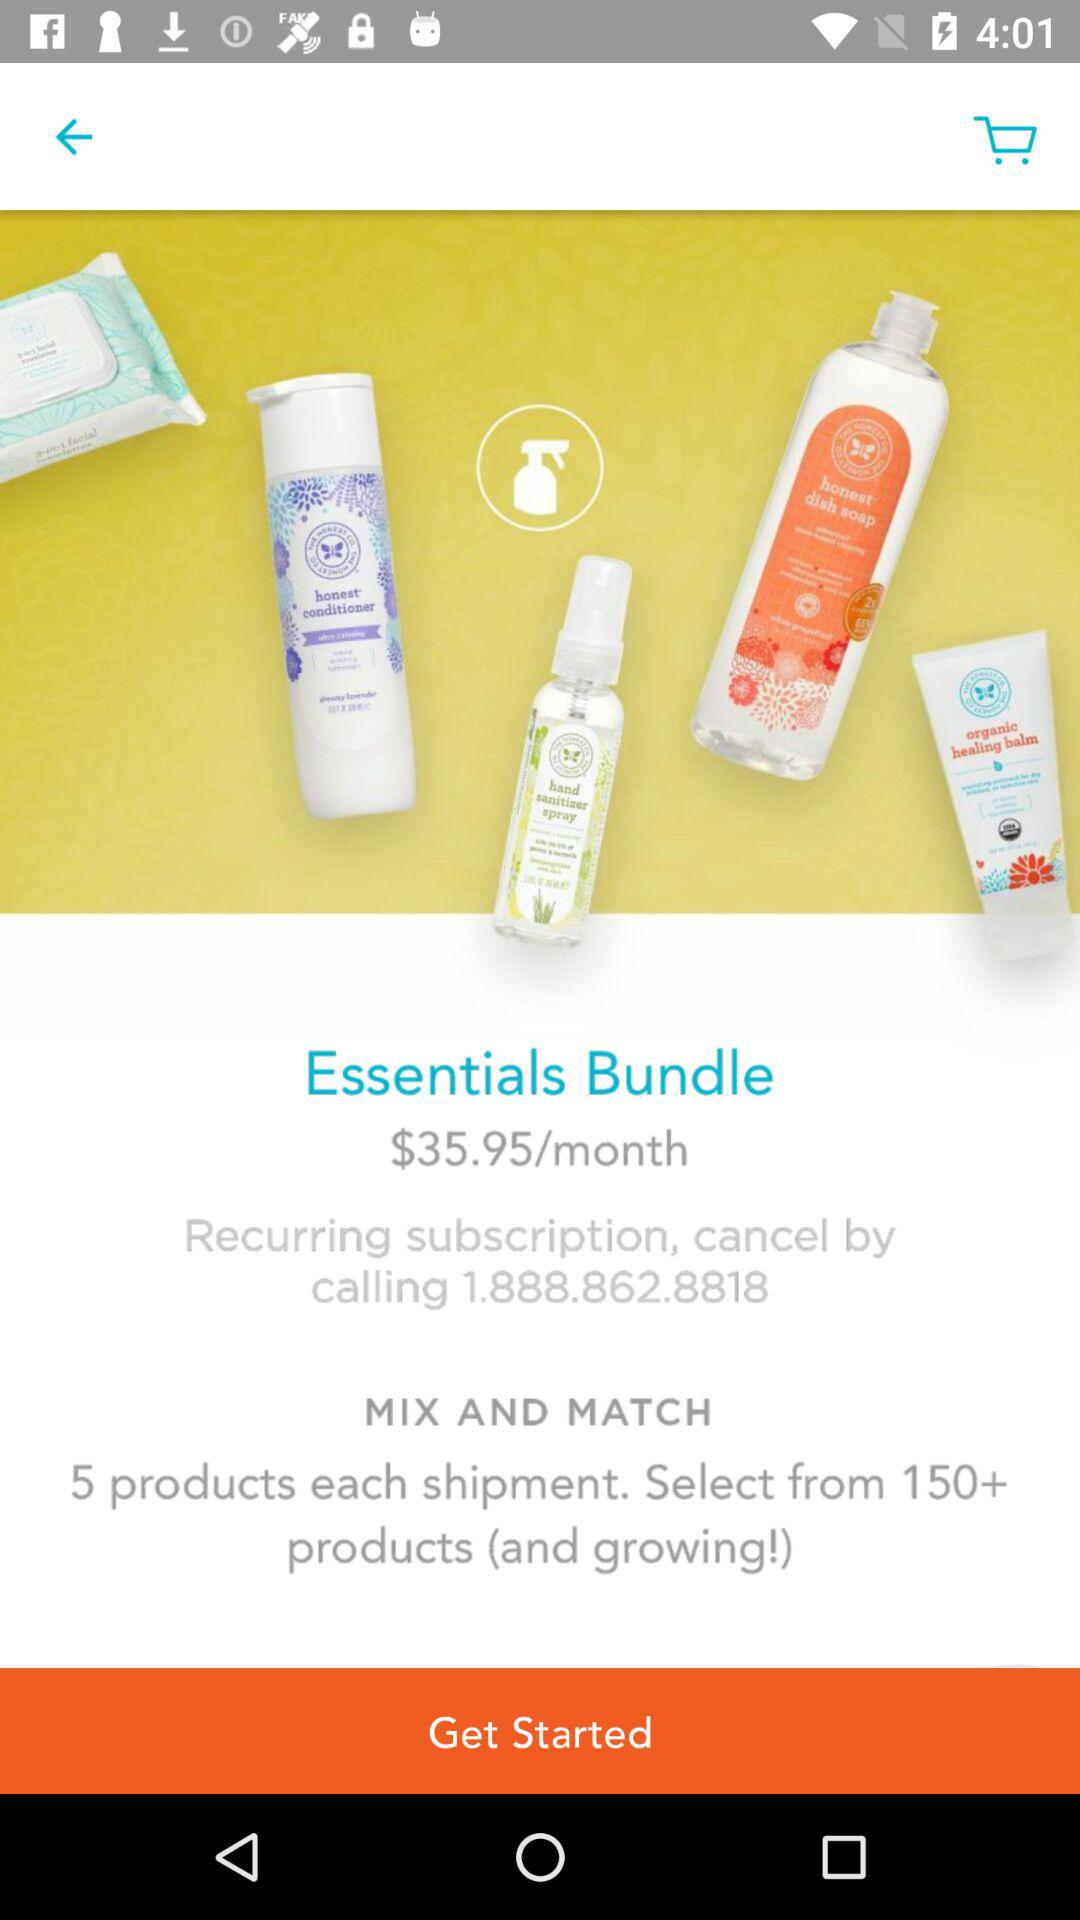How many products can I select from?
Answer the question using a single word or phrase. 150+ 